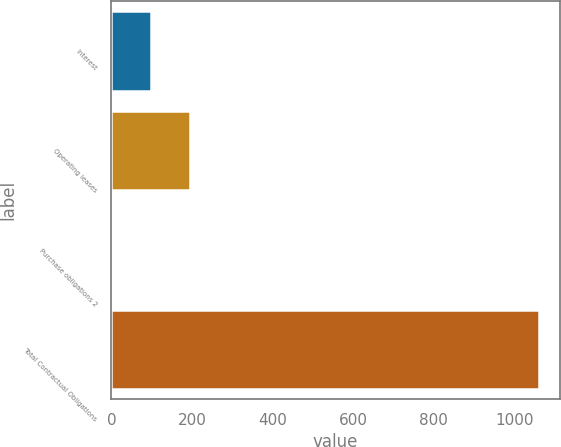<chart> <loc_0><loc_0><loc_500><loc_500><bar_chart><fcel>Interest<fcel>Operating leases<fcel>Purchase obligations 2<fcel>Total Contractual Obligations<nl><fcel>99.1<fcel>195.2<fcel>3<fcel>1060.1<nl></chart> 